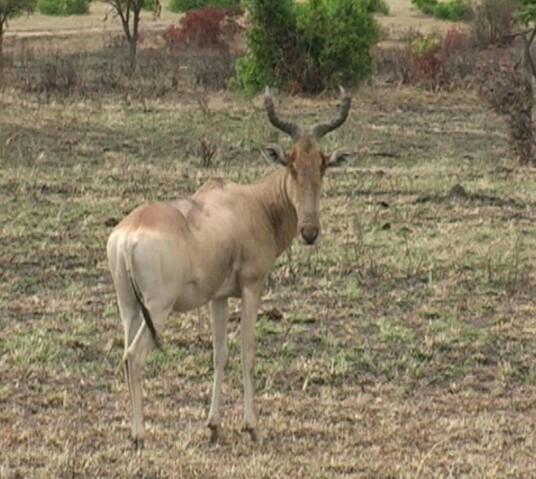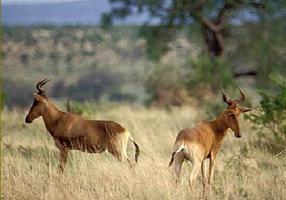The first image is the image on the left, the second image is the image on the right. Assess this claim about the two images: "The right image contains at twice as many horned animals as the left image.". Correct or not? Answer yes or no. Yes. The first image is the image on the left, the second image is the image on the right. For the images displayed, is the sentence "The right image shows two antelope in the grass." factually correct? Answer yes or no. Yes. 